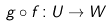<formula> <loc_0><loc_0><loc_500><loc_500>g \circ f \colon U \rightarrow W</formula> 